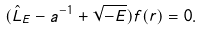Convert formula to latex. <formula><loc_0><loc_0><loc_500><loc_500>( \hat { L } _ { E } - a ^ { - 1 } + \sqrt { - E } ) f ( { r } ) = 0 .</formula> 